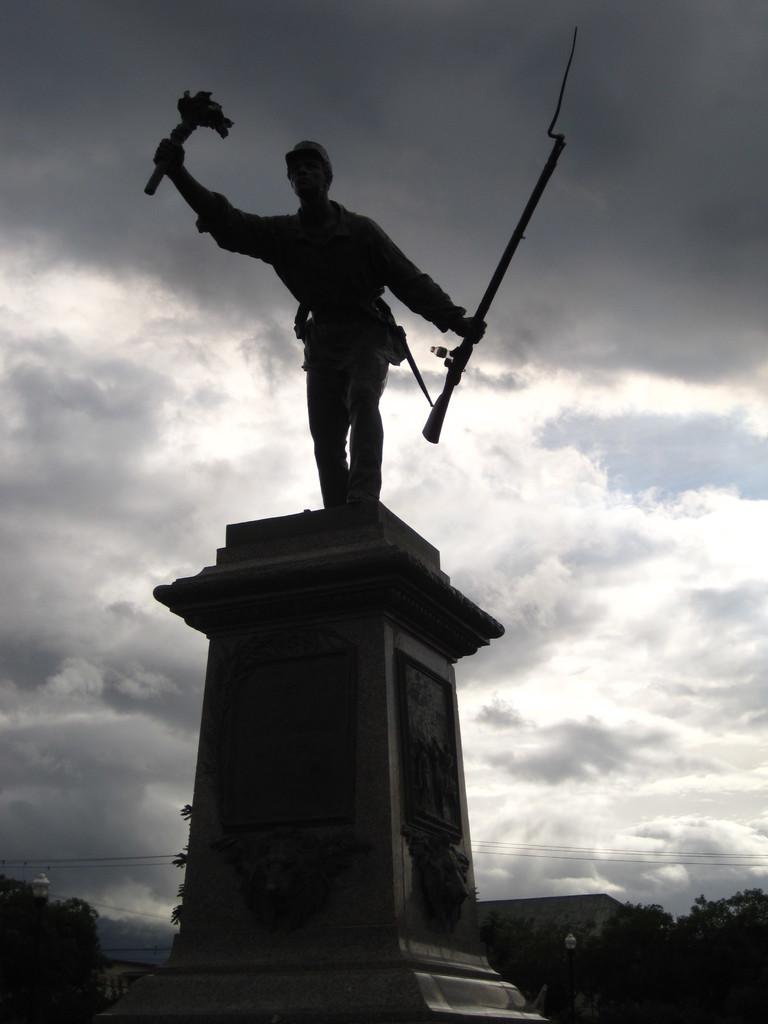What is the main subject in the center of the image? There is a statue in the center of the image. What can be seen in the background of the image? There are trees in the background of the image. How would you describe the sky in the image? The sky is cloudy in the image. What type of lipstick is the pig wearing in the image? There is no pig or lipstick present in the image; it features a statue and trees in the background. 